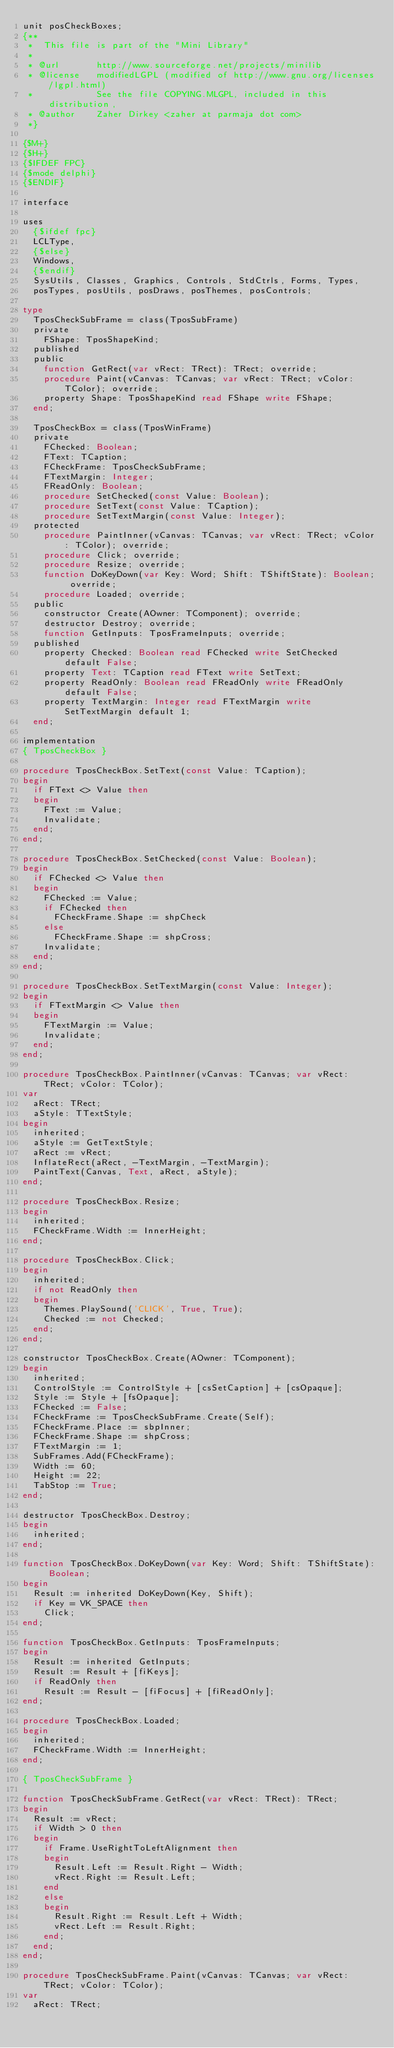<code> <loc_0><loc_0><loc_500><loc_500><_Pascal_>unit posCheckBoxes;
{**
 *  This file is part of the "Mini Library"
 *
 * @url       http://www.sourceforge.net/projects/minilib
 * @license   modifiedLGPL (modified of http://www.gnu.org/licenses/lgpl.html)
 *            See the file COPYING.MLGPL, included in this distribution,
 * @author    Zaher Dirkey <zaher at parmaja dot com>
 *}

{$M+}
{$H+}
{$IFDEF FPC}
{$mode delphi}
{$ENDIF}

interface

uses
  {$ifdef fpc}
  LCLType,
  {$else}
  Windows,
  {$endif}
  SysUtils, Classes, Graphics, Controls, StdCtrls, Forms, Types,
  posTypes, posUtils, posDraws, posThemes, posControls;

type
  TposCheckSubFrame = class(TposSubFrame)
  private
    FShape: TposShapeKind;
  published
  public
    function GetRect(var vRect: TRect): TRect; override;
    procedure Paint(vCanvas: TCanvas; var vRect: TRect; vColor: TColor); override;
    property Shape: TposShapeKind read FShape write FShape;
  end;

  TposCheckBox = class(TposWinFrame)
  private
    FChecked: Boolean;
    FText: TCaption;
    FCheckFrame: TposCheckSubFrame;
    FTextMargin: Integer;
    FReadOnly: Boolean;
    procedure SetChecked(const Value: Boolean);
    procedure SetText(const Value: TCaption);
    procedure SetTextMargin(const Value: Integer);
  protected
    procedure PaintInner(vCanvas: TCanvas; var vRect: TRect; vColor: TColor); override;
    procedure Click; override;
    procedure Resize; override;
    function DoKeyDown(var Key: Word; Shift: TShiftState): Boolean; override;
    procedure Loaded; override;
  public
    constructor Create(AOwner: TComponent); override;
    destructor Destroy; override;
    function GetInputs: TposFrameInputs; override;
  published
    property Checked: Boolean read FChecked write SetChecked default False;
    property Text: TCaption read FText write SetText;
    property ReadOnly: Boolean read FReadOnly write FReadOnly default False;
    property TextMargin: Integer read FTextMargin write SetTextMargin default 1;
  end;

implementation
{ TposCheckBox }

procedure TposCheckBox.SetText(const Value: TCaption);
begin
  if FText <> Value then
  begin
    FText := Value;
    Invalidate;
  end;
end;

procedure TposCheckBox.SetChecked(const Value: Boolean);
begin
  if FChecked <> Value then
  begin
    FChecked := Value;
    if FChecked then
      FCheckFrame.Shape := shpCheck
    else
      FCheckFrame.Shape := shpCross;
    Invalidate;
  end;
end;

procedure TposCheckBox.SetTextMargin(const Value: Integer);
begin
  if FTextMargin <> Value then
  begin
    FTextMargin := Value;
    Invalidate;
  end;
end;

procedure TposCheckBox.PaintInner(vCanvas: TCanvas; var vRect: TRect; vColor: TColor);
var
  aRect: TRect;
  aStyle: TTextStyle;
begin
  inherited;
  aStyle := GetTextStyle;
  aRect := vRect;
  InflateRect(aRect, -TextMargin, -TextMargin);
  PaintText(Canvas, Text, aRect, aStyle);
end;

procedure TposCheckBox.Resize;
begin
  inherited;
  FCheckFrame.Width := InnerHeight;
end;

procedure TposCheckBox.Click;
begin
  inherited;
  if not ReadOnly then
  begin
    Themes.PlaySound('CLICK', True, True);
    Checked := not Checked;
  end;
end;

constructor TposCheckBox.Create(AOwner: TComponent);
begin
  inherited;
  ControlStyle := ControlStyle + [csSetCaption] + [csOpaque];
  Style := Style + [fsOpaque];
  FChecked := False;
  FCheckFrame := TposCheckSubFrame.Create(Self);
  FCheckFrame.Place := sbpInner;
  FCheckFrame.Shape := shpCross;
  FTextMargin := 1;
  SubFrames.Add(FCheckFrame);
  Width := 60;
  Height := 22;
  TabStop := True;
end;

destructor TposCheckBox.Destroy;
begin
  inherited;
end;

function TposCheckBox.DoKeyDown(var Key: Word; Shift: TShiftState): Boolean;
begin
  Result := inherited DoKeyDown(Key, Shift);
  if Key = VK_SPACE then
    Click;
end;

function TposCheckBox.GetInputs: TposFrameInputs;
begin
  Result := inherited GetInputs;
  Result := Result + [fiKeys];
  if ReadOnly then
    Result := Result - [fiFocus] + [fiReadOnly];
end;

procedure TposCheckBox.Loaded;
begin
  inherited;
  FCheckFrame.Width := InnerHeight;
end;

{ TposCheckSubFrame }

function TposCheckSubFrame.GetRect(var vRect: TRect): TRect;
begin
  Result := vRect;
  if Width > 0 then
  begin
    if Frame.UseRightToLeftAlignment then
    begin
      Result.Left := Result.Right - Width;
      vRect.Right := Result.Left;
    end
    else
    begin
      Result.Right := Result.Left + Width;
      vRect.Left := Result.Right;
    end;
  end;
end;

procedure TposCheckSubFrame.Paint(vCanvas: TCanvas; var vRect: TRect; vColor: TColor);
var
  aRect: TRect;</code> 